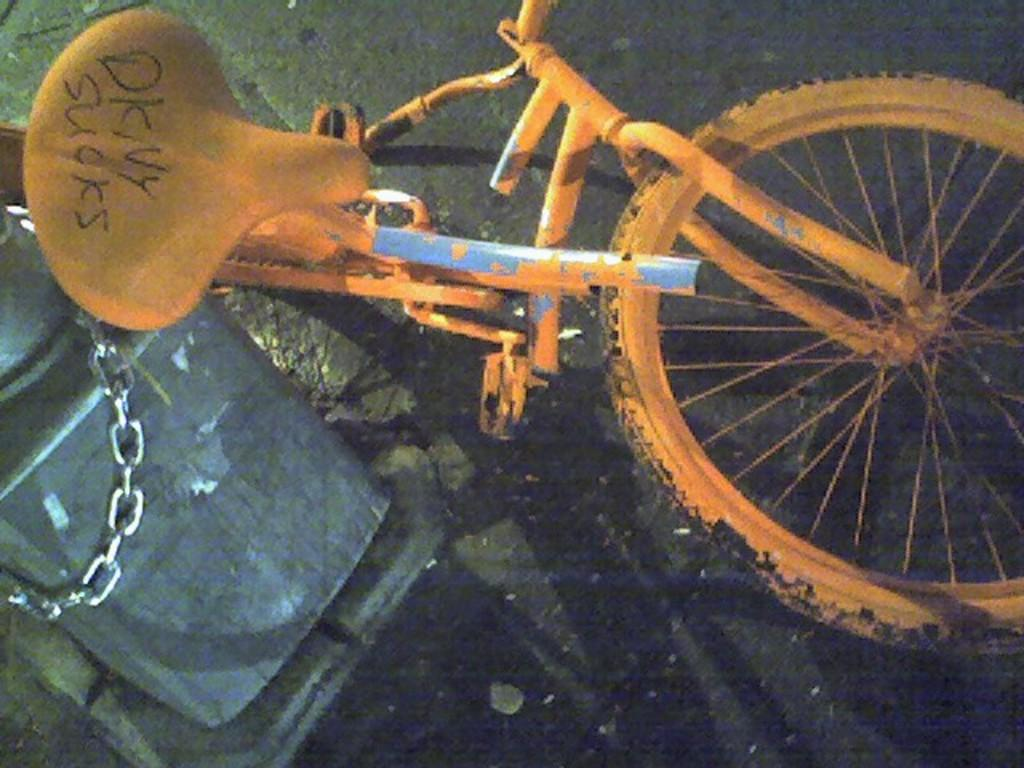What is the main object in the image? There is a bicycle in the image. What can be seen on the left side of the image? There is a bin on the left side of the image. What type of surface is visible at the bottom of the image? There is a road visible at the bottom of the image. How does the bicycle affect the digestion process in the image? The image does not show any digestion process, and the bicycle is not related to digestion. 